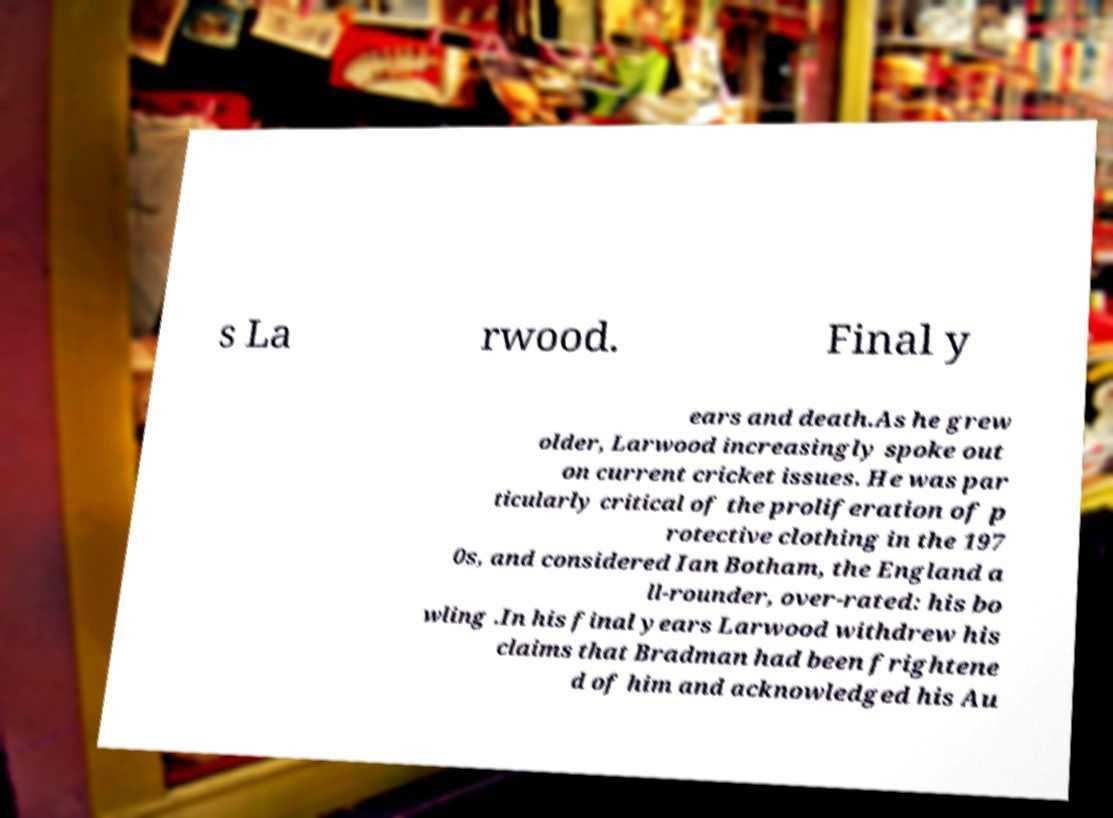I need the written content from this picture converted into text. Can you do that? s La rwood. Final y ears and death.As he grew older, Larwood increasingly spoke out on current cricket issues. He was par ticularly critical of the proliferation of p rotective clothing in the 197 0s, and considered Ian Botham, the England a ll-rounder, over-rated: his bo wling .In his final years Larwood withdrew his claims that Bradman had been frightene d of him and acknowledged his Au 